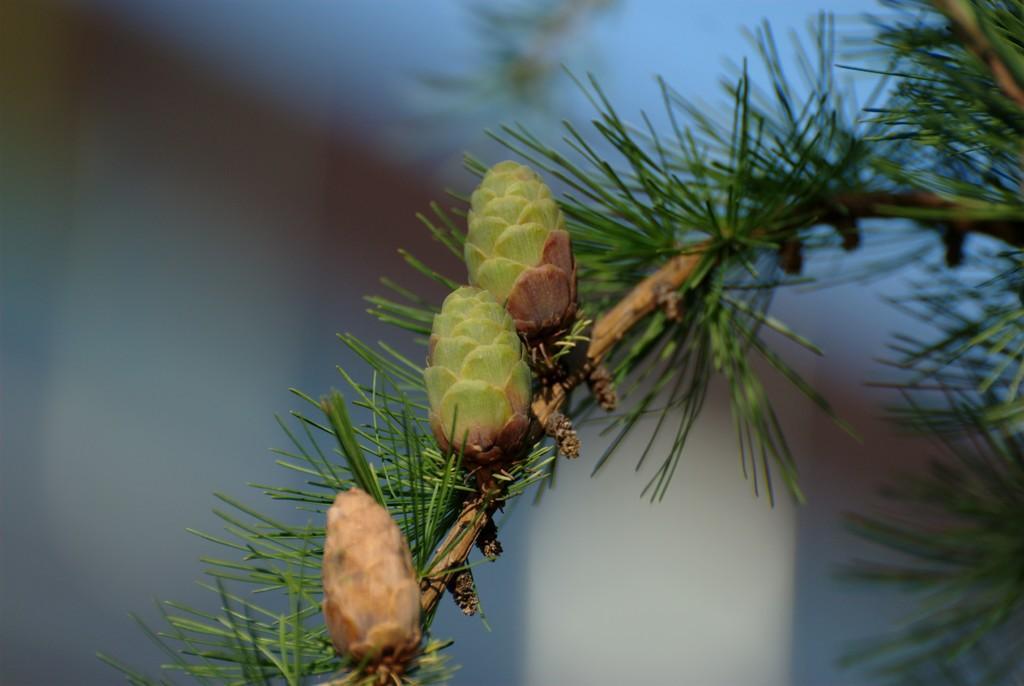Describe this image in one or two sentences. Here I can see a pinus serotina fruit to a stem along with the leaves. The background is blurred. 